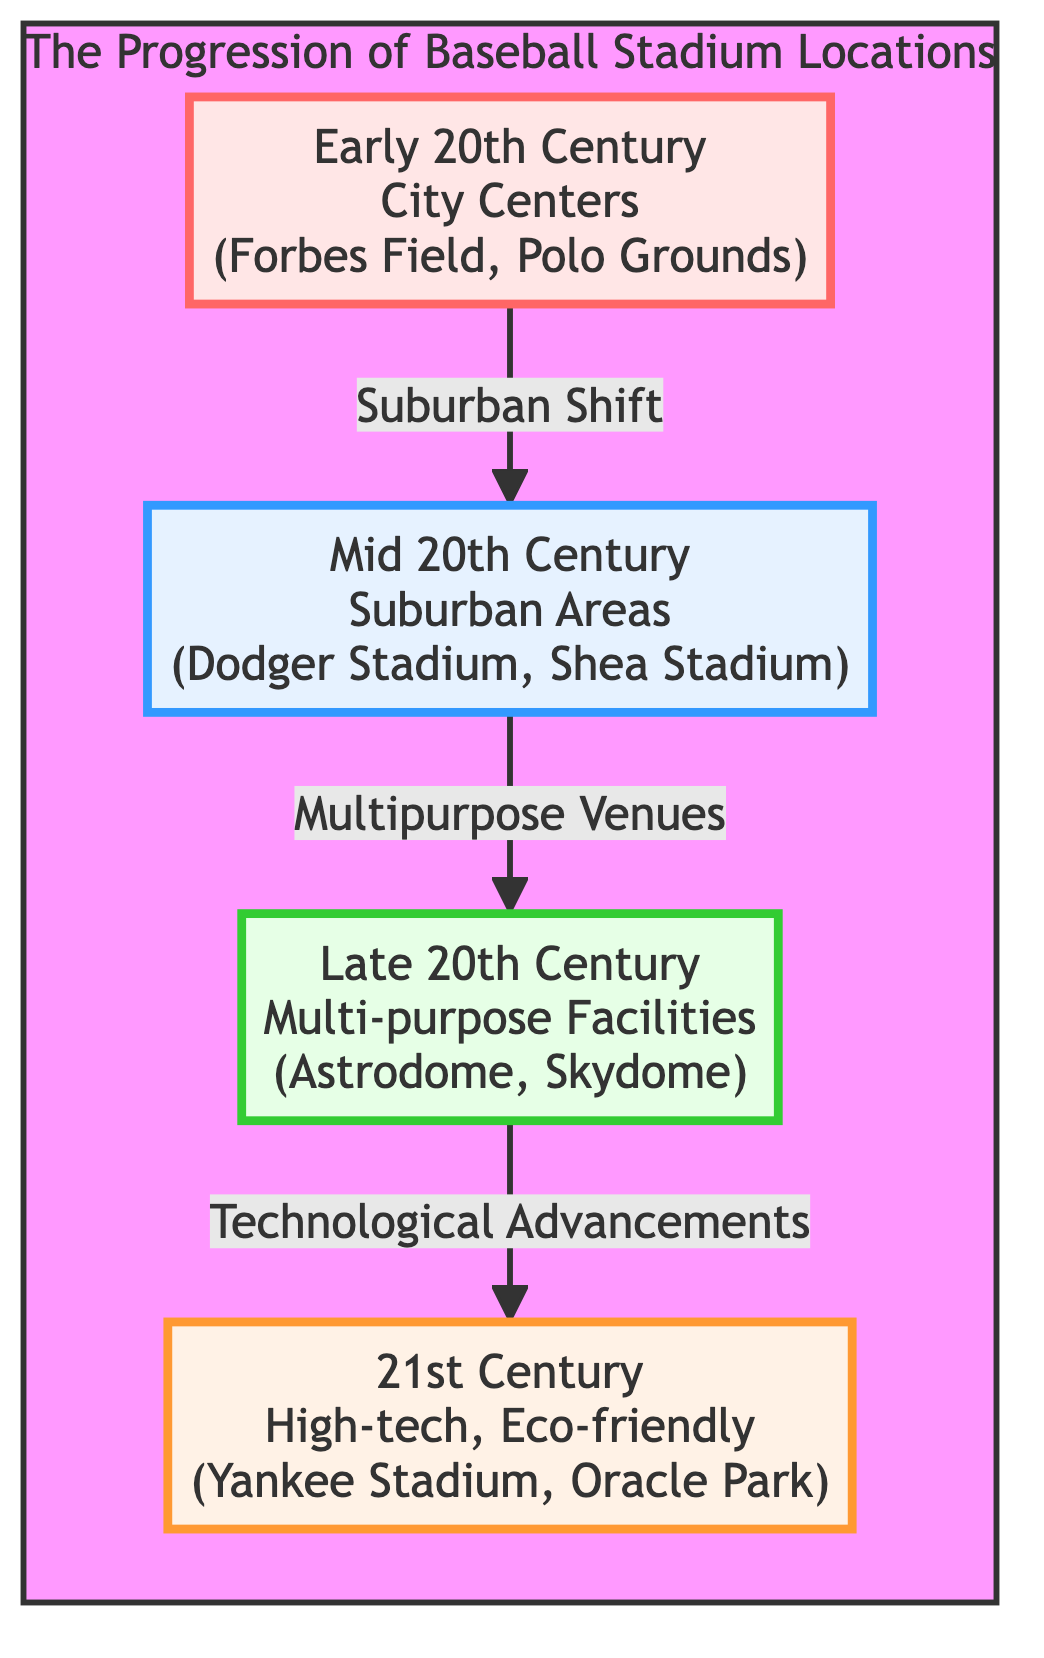What stadiums are mentioned in the Early 20th Century node? The Early 20th Century node lists Forbes Field and Polo Grounds as examples of stadiums from this period, both located in city centers.
Answer: Forbes Field, Polo Grounds What type of locations did stadiums shift to in the Mid 20th Century? The diagram indicates that stadiums shifted to suburban areas in the Mid 20th Century, as represented by Dodger Stadium and Shea Stadium.
Answer: Suburban Areas What event or trend connects the node for Mid 20th Century to Late 20th Century? The flow from the Mid 20th Century node to the Late 20th Century node is characterized by the concept of "Multipurpose Venues," suggesting a trend in the design and use of stadiums.
Answer: Multipurpose Venues Which node represents the 21st Century type of stadiums? The node labeled "21st Century" in the diagram specifically addresses contemporary stadiums characterized as high-tech and eco-friendly, including Yankee Stadium and Oracle Park.
Answer: 21st Century How many main nodes are there in the diagram? The diagram contains four primary nodes representing different eras of baseball stadium locations and characteristics, from the Early 20th Century to the 21st Century.
Answer: Four What technological advancement is noted for the transition to the 21st Century? The node connection indicates that "Technological Advancements" is a key concept for the transition from Late 20th Century stadiums to those constructed in the 21st Century.
Answer: Technological Advancements In what decade did stadiums primarily transition to multi-purpose facilities? The transition to multi-purpose facilities, as indicated in the Late 20th Century node, suggests that this trend predominantly occurred during this era.
Answer: Late 20th Century What visually defines the first node in this diagram? The first node is visually defined by the description and examples of stadiums that existed during the early part of the 20th century, set in a backdrop of city centers.
Answer: Early 20th Century 